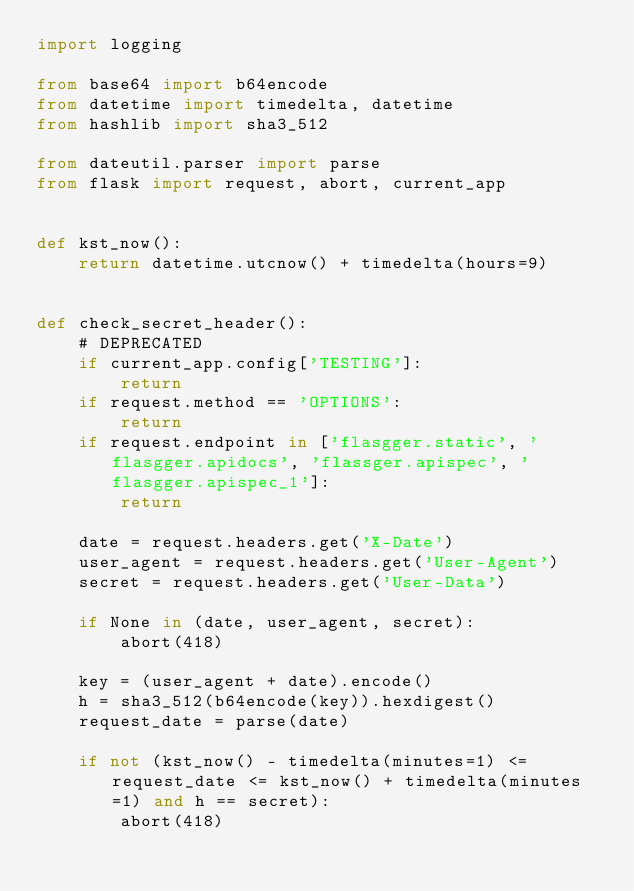Convert code to text. <code><loc_0><loc_0><loc_500><loc_500><_Python_>import logging

from base64 import b64encode
from datetime import timedelta, datetime
from hashlib import sha3_512

from dateutil.parser import parse
from flask import request, abort, current_app


def kst_now():
    return datetime.utcnow() + timedelta(hours=9)


def check_secret_header():
    # DEPRECATED
    if current_app.config['TESTING']:
        return
    if request.method == 'OPTIONS':
        return
    if request.endpoint in ['flasgger.static', 'flasgger.apidocs', 'flassger.apispec', 'flasgger.apispec_1']:
        return

    date = request.headers.get('X-Date')
    user_agent = request.headers.get('User-Agent')
    secret = request.headers.get('User-Data')

    if None in (date, user_agent, secret):
        abort(418)

    key = (user_agent + date).encode()
    h = sha3_512(b64encode(key)).hexdigest()
    request_date = parse(date)

    if not (kst_now() - timedelta(minutes=1) <= request_date <= kst_now() + timedelta(minutes=1) and h == secret):
        abort(418)
</code> 